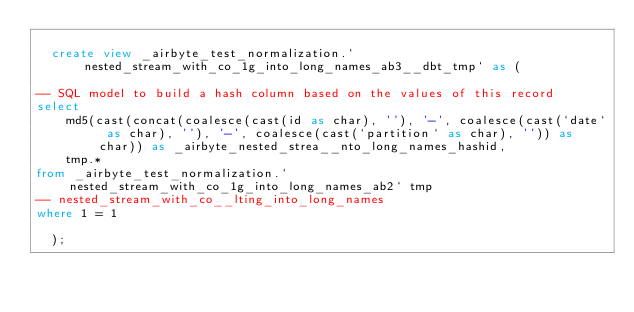Convert code to text. <code><loc_0><loc_0><loc_500><loc_500><_SQL_>
  create view _airbyte_test_normalization.`nested_stream_with_co_1g_into_long_names_ab3__dbt_tmp` as (
    
-- SQL model to build a hash column based on the values of this record
select
    md5(cast(concat(coalesce(cast(id as char), ''), '-', coalesce(cast(`date` as char), ''), '-', coalesce(cast(`partition` as char), '')) as char)) as _airbyte_nested_strea__nto_long_names_hashid,
    tmp.*
from _airbyte_test_normalization.`nested_stream_with_co_1g_into_long_names_ab2` tmp
-- nested_stream_with_co__lting_into_long_names
where 1 = 1

  );
</code> 